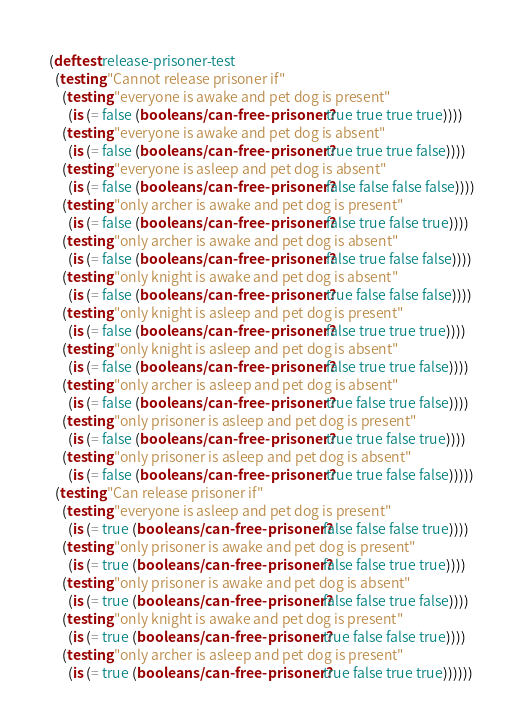<code> <loc_0><loc_0><loc_500><loc_500><_Clojure_>
(deftest release-prisoner-test
  (testing "Cannot release prisoner if"
    (testing "everyone is awake and pet dog is present"
      (is (= false (booleans/can-free-prisoner? true true true true))))
    (testing "everyone is awake and pet dog is absent"
      (is (= false (booleans/can-free-prisoner? true true true false))))
    (testing "everyone is asleep and pet dog is absent"
      (is (= false (booleans/can-free-prisoner? false false false false))))
    (testing "only archer is awake and pet dog is present"
      (is (= false (booleans/can-free-prisoner? false true false true))))
    (testing "only archer is awake and pet dog is absent"
      (is (= false (booleans/can-free-prisoner? false true false false))))
    (testing "only knight is awake and pet dog is absent"
      (is (= false (booleans/can-free-prisoner? true false false false))))
    (testing "only knight is asleep and pet dog is present"
      (is (= false (booleans/can-free-prisoner? false true true true))))
    (testing "only knight is asleep and pet dog is absent"
      (is (= false (booleans/can-free-prisoner? false true true false))))
    (testing "only archer is asleep and pet dog is absent"
      (is (= false (booleans/can-free-prisoner? true false true false))))
    (testing "only prisoner is asleep and pet dog is present"
      (is (= false (booleans/can-free-prisoner? true true false true))))
    (testing "only prisoner is asleep and pet dog is absent"
      (is (= false (booleans/can-free-prisoner? true true false false)))))
  (testing "Can release prisoner if"
    (testing "everyone is asleep and pet dog is present"
      (is (= true (booleans/can-free-prisoner? false false false true))))
    (testing "only prisoner is awake and pet dog is present"
      (is (= true (booleans/can-free-prisoner? false false true true))))
    (testing "only prisoner is awake and pet dog is absent"
      (is (= true (booleans/can-free-prisoner? false false true false))))
    (testing "only knight is awake and pet dog is present"
      (is (= true (booleans/can-free-prisoner? true false false true))))
    (testing "only archer is asleep and pet dog is present"
      (is (= true (booleans/can-free-prisoner? true false true true))))))
</code> 